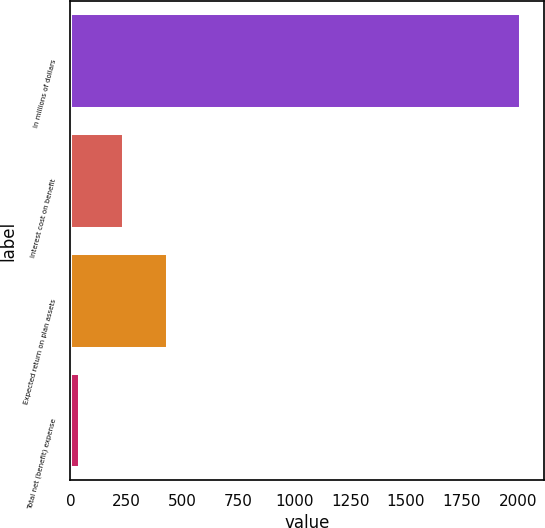Convert chart. <chart><loc_0><loc_0><loc_500><loc_500><bar_chart><fcel>In millions of dollars<fcel>Interest cost on benefit<fcel>Expected return on plan assets<fcel>Total net (benefit) expense<nl><fcel>2014<fcel>238.3<fcel>435.6<fcel>41<nl></chart> 